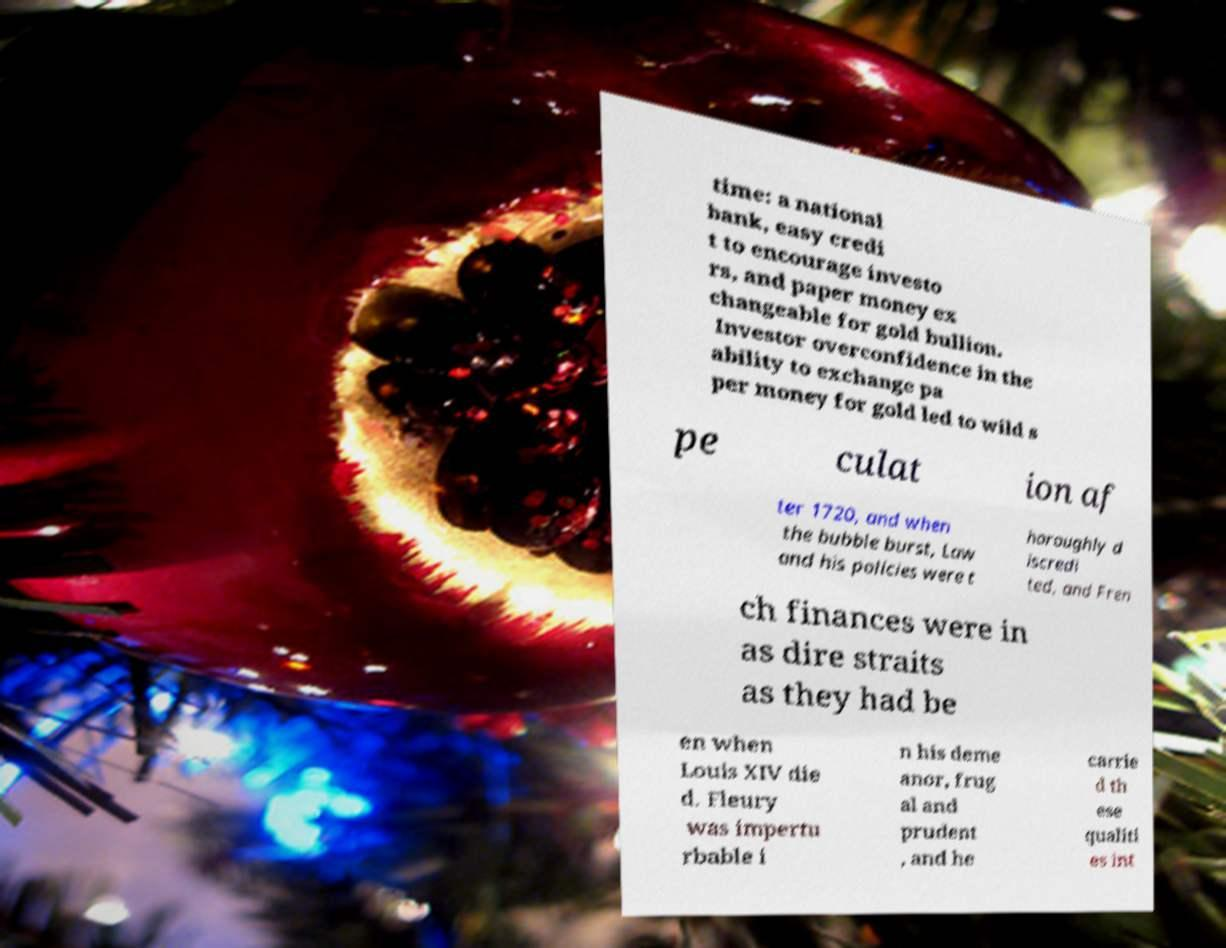Could you assist in decoding the text presented in this image and type it out clearly? time: a national bank, easy credi t to encourage investo rs, and paper money ex changeable for gold bullion. Investor overconfidence in the ability to exchange pa per money for gold led to wild s pe culat ion af ter 1720, and when the bubble burst, Law and his policies were t horoughly d iscredi ted, and Fren ch finances were in as dire straits as they had be en when Louis XIV die d. Fleury was impertu rbable i n his deme anor, frug al and prudent , and he carrie d th ese qualiti es int 